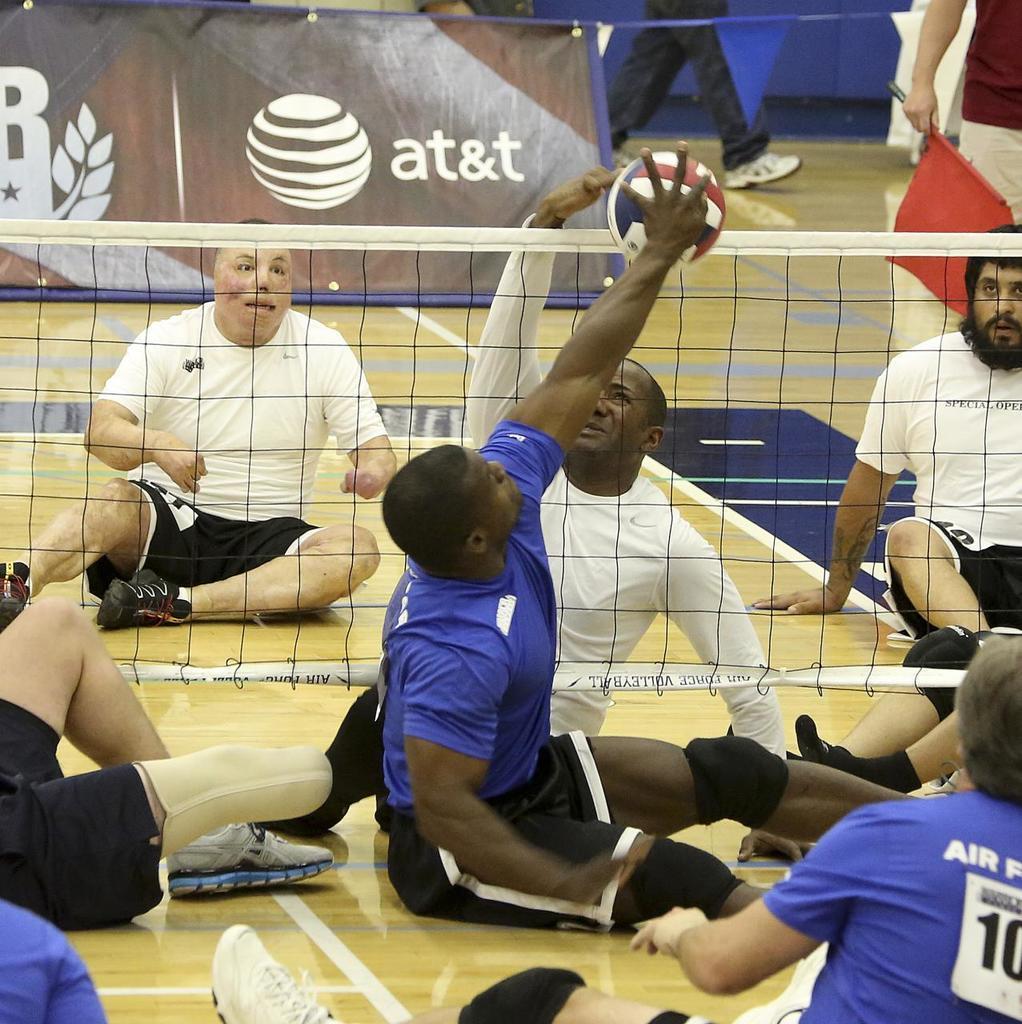Can you describe this image briefly? In this picture I can see some people are sitting on the ground and playing with ball, in between them there is a net behind few people are walking. 